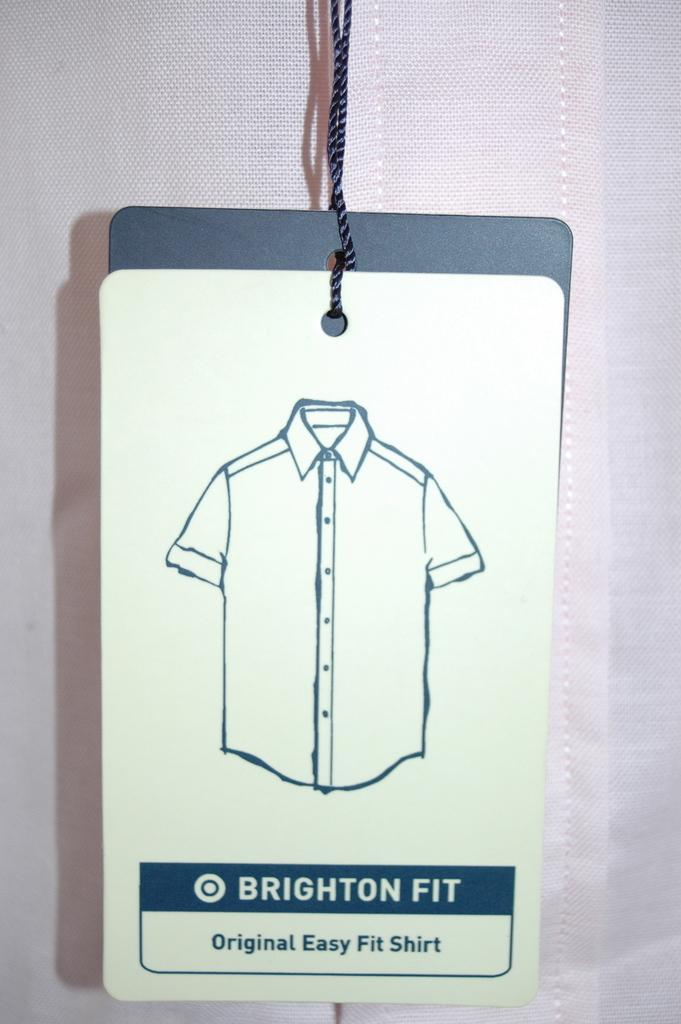What type of clothing item is in the image? There is a shirt in the image. What feature can be found on the shirt? The shirt has a tag. What is depicted on the tag? There is an image of a shirt on the tag. What information is provided on the tag? There is text on the tag. What type of punishment is depicted on the tag of the shirt? There is no punishment depicted on the tag of the shirt; it only contains an image of the shirt and text. 